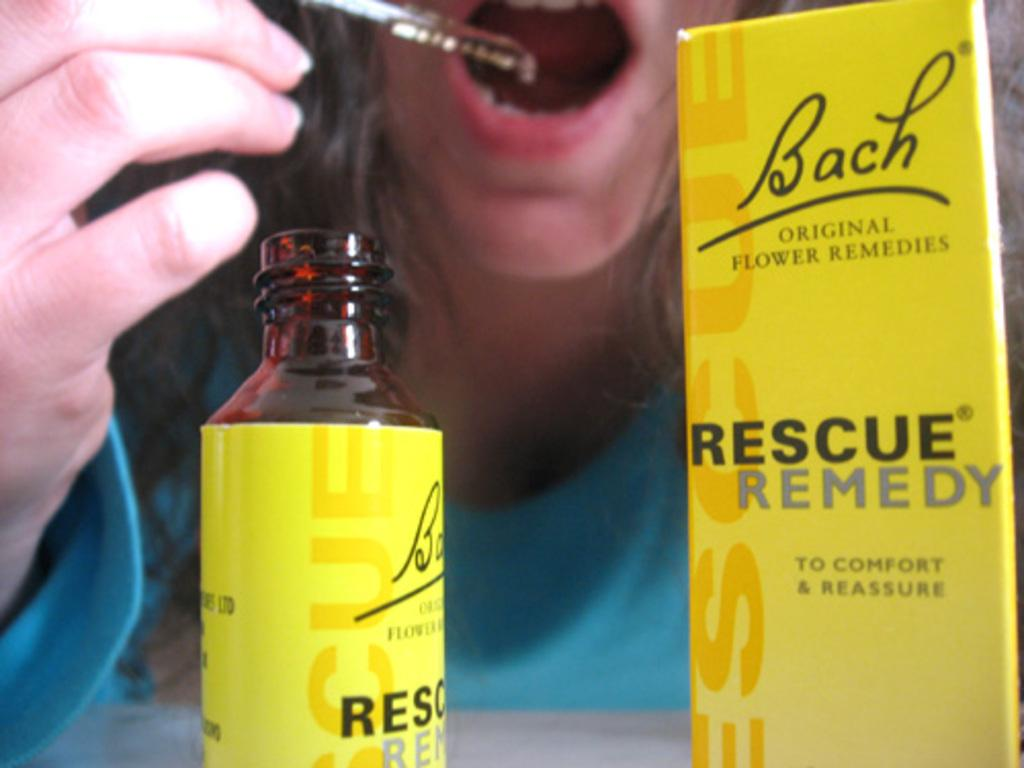What color is the bottle in the image? The bottle in the image is yellow. What other yellow object can be seen in the image? There is a yellow box in the image. What is the woman in the image doing? The woman is sitting and holding an object. What action is the woman taking with the object? The woman is taking the object into her mouth. Can you tell me what type of prose the woman is reading in the image? There is no indication of any reading material or prose in the image. What kind of frog can be seen sitting on the yellow box in the image? There is no frog present in the image. 